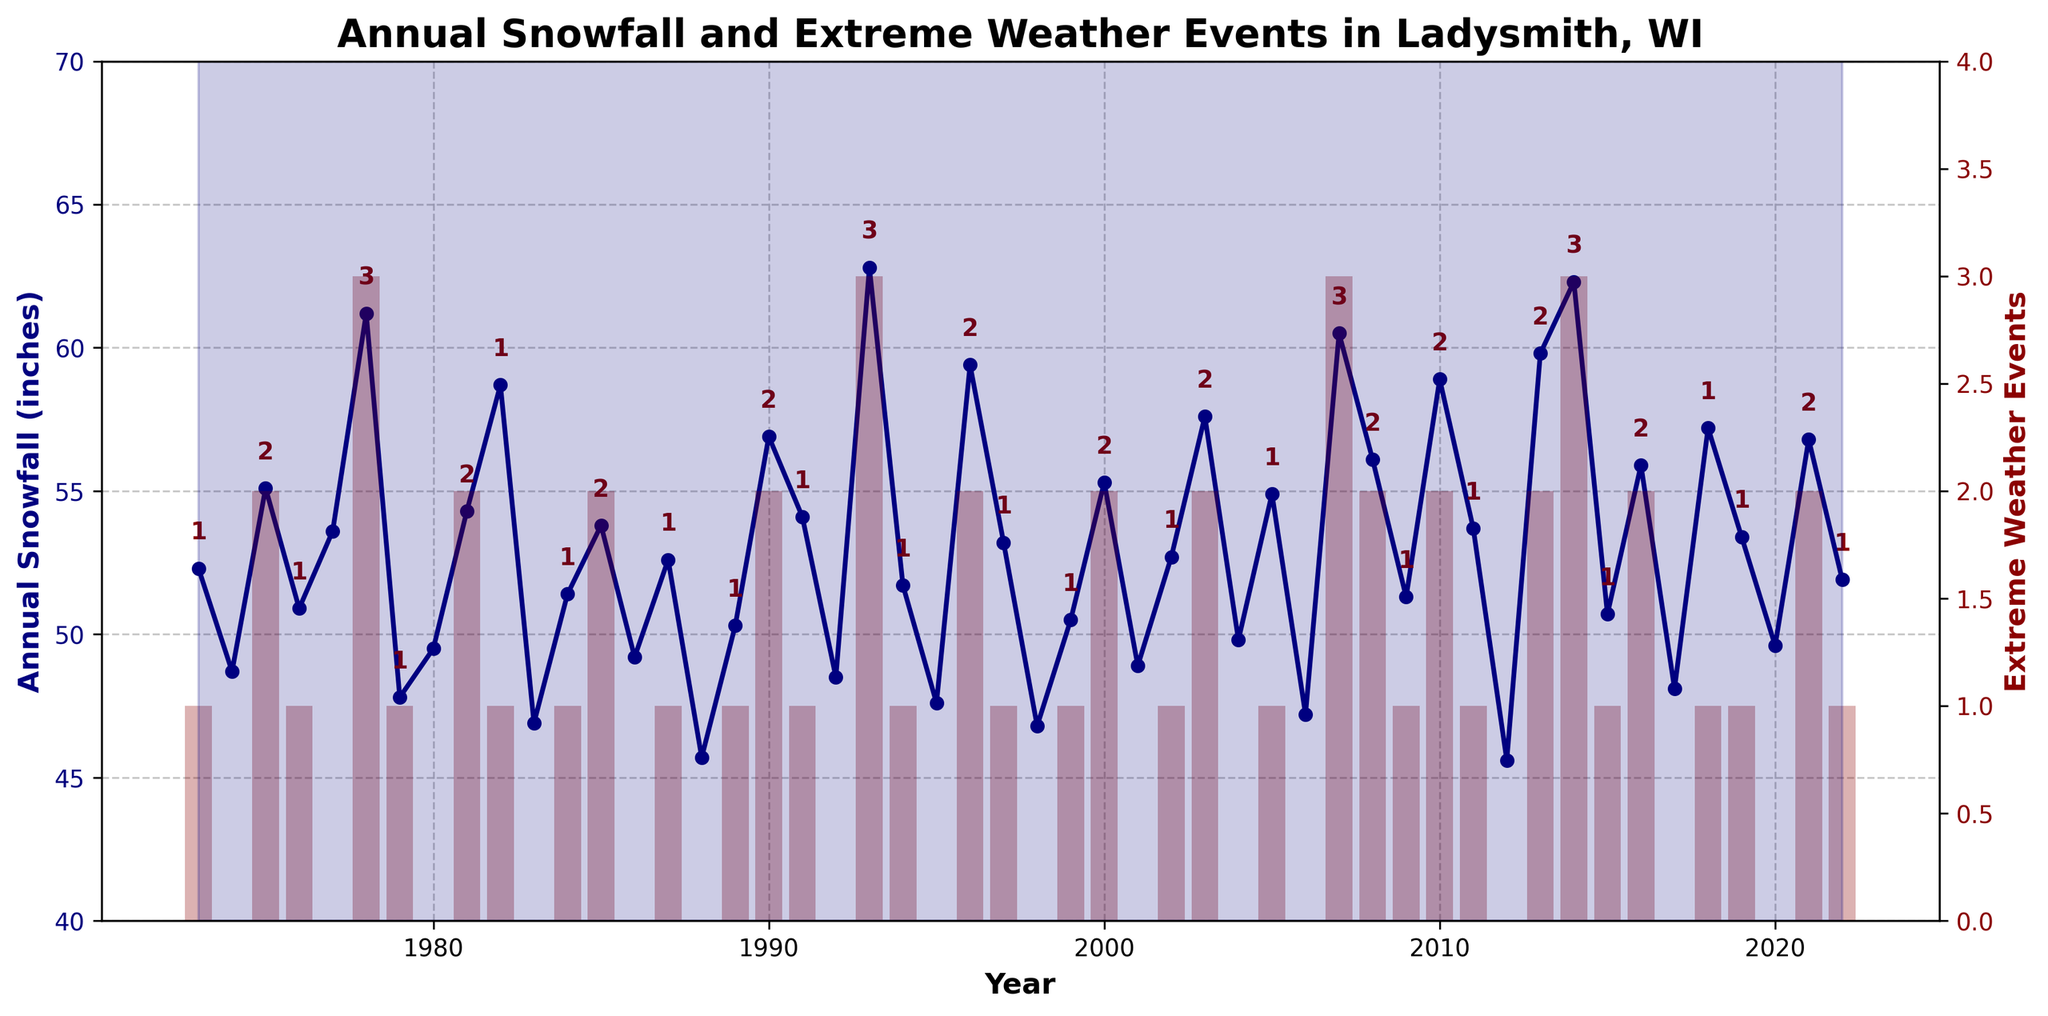What was the year with the highest annual snowfall? By examining the line chart, the highest point on the snowfall line should be identified. The year associated with this peak is the answer.
Answer: 1993 In which years did Ladysmith, WI experience the most extreme weather events? Visually identify the tallest red bars, which represent extreme weather events, and note the corresponding years.
Answer: 1993, 2007, 2014 What is the average annual snowfall over the last 50 years? Sum all the annual snowfall values and divide by 50 (total number of years).
Answer: 53.5 inches How many years experienced more than one extreme weather event? Count the number of bars where the height exceeds one.
Answer: 21 years Compare the snowfall of 1990 and 2000. Which year had more snowfall? Locate the data points for 1990 and 2000 on the snowfall line and compare their heights.
Answer: 1990 What is the difference in snowfall between 1978 and 2006? Find the snowfall values for 1978 and 2006 on the line chart and subtract the smaller from the larger value.
Answer: 14 inches Which year had the least snowfall, and what was the amount? Identify the lowest point on the snowfall line and its corresponding year.
Answer: 1988, 45.7 inches Is there a visible correlation between the number of extreme weather events and annual snowfall? Observe if there are any noticeable patterns where a high number of extreme weather events coincide with higher snowfall levels, or vice versa, in the chart.
Answer: There appears to be a weak correlation, as some years with many extreme events also have high snowfall In which decade did Ladysmith, WI see the most variation in snowfall? Compare the amplitude (distance from the highest to the lowest snowfall) for each decade and determine which decade had the largest range.
Answer: 1990s How does the snowfall trend over time? Increase, decrease, or no clear trend? Look at the overall trajectory of the snowfall line from beginning to end to assess whether it generally goes up, down, or remains flat.
Answer: No clear trend 